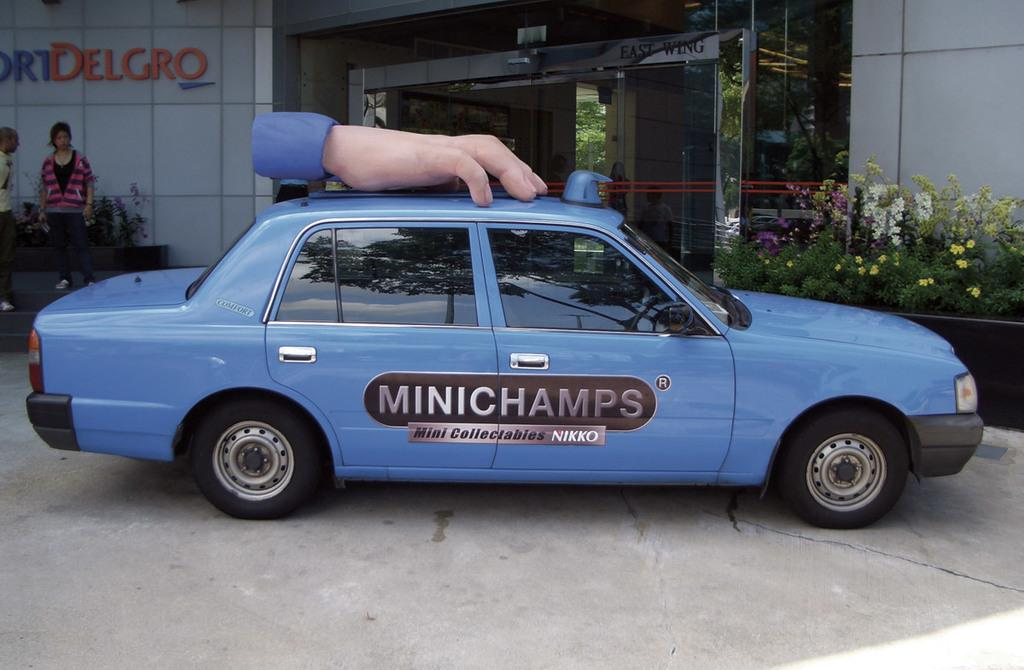<image>
Provide a brief description of the given image. a blue minichamps car by mini collectabies nikko 